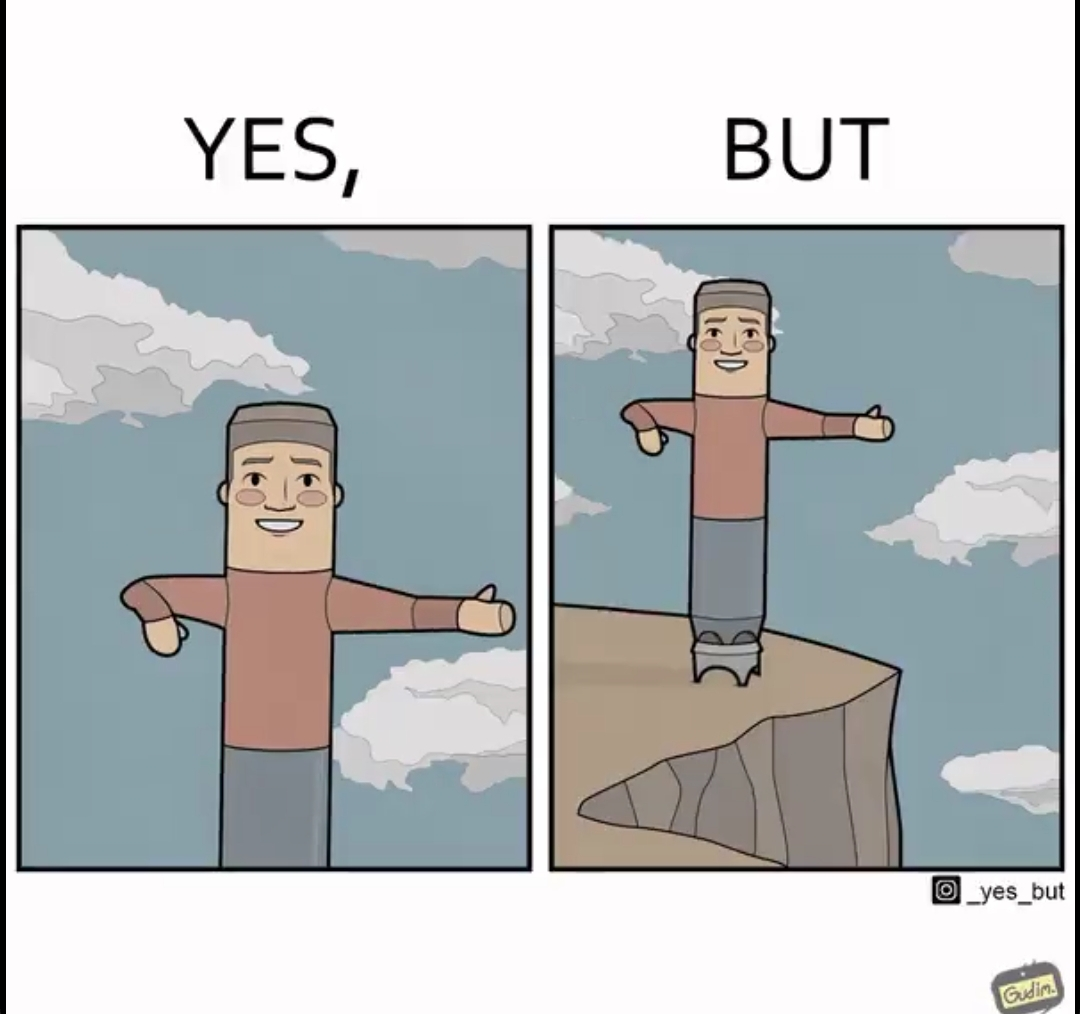Describe the contrast between the left and right parts of this image. In the left part of the image: a statue with a smile, extending its hands to one side probably directing to some path In the right part of the image: a statue with a smile, extending its hands to one side probably directing to some path guiding at the wrong side of the road maybe unintentionally misplaced 